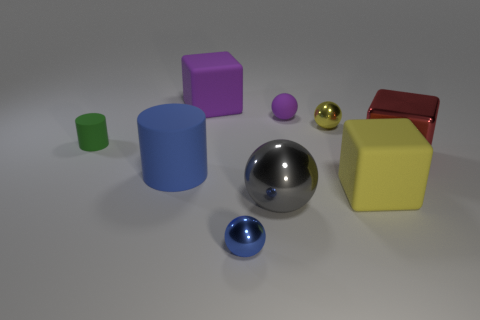Do the tiny sphere to the left of the small purple thing and the matte ball have the same color?
Provide a short and direct response. No. The big object that is in front of the large purple object and to the left of the gray metal ball is made of what material?
Your answer should be very brief. Rubber. What size is the green matte cylinder?
Make the answer very short. Small. Do the large cylinder and the big rubber cube in front of the big red cube have the same color?
Offer a very short reply. No. What number of other things are the same color as the tiny matte cylinder?
Provide a succinct answer. 0. There is a blue thing in front of the blue matte cylinder; is it the same size as the cylinder behind the blue cylinder?
Offer a terse response. Yes. There is a large rubber cube that is behind the large red metal object; what is its color?
Make the answer very short. Purple. Are there fewer large objects on the left side of the yellow shiny ball than large metal balls?
Make the answer very short. No. Do the yellow sphere and the big yellow cube have the same material?
Ensure brevity in your answer.  No. What size is the blue shiny thing that is the same shape as the big gray shiny object?
Provide a short and direct response. Small. 